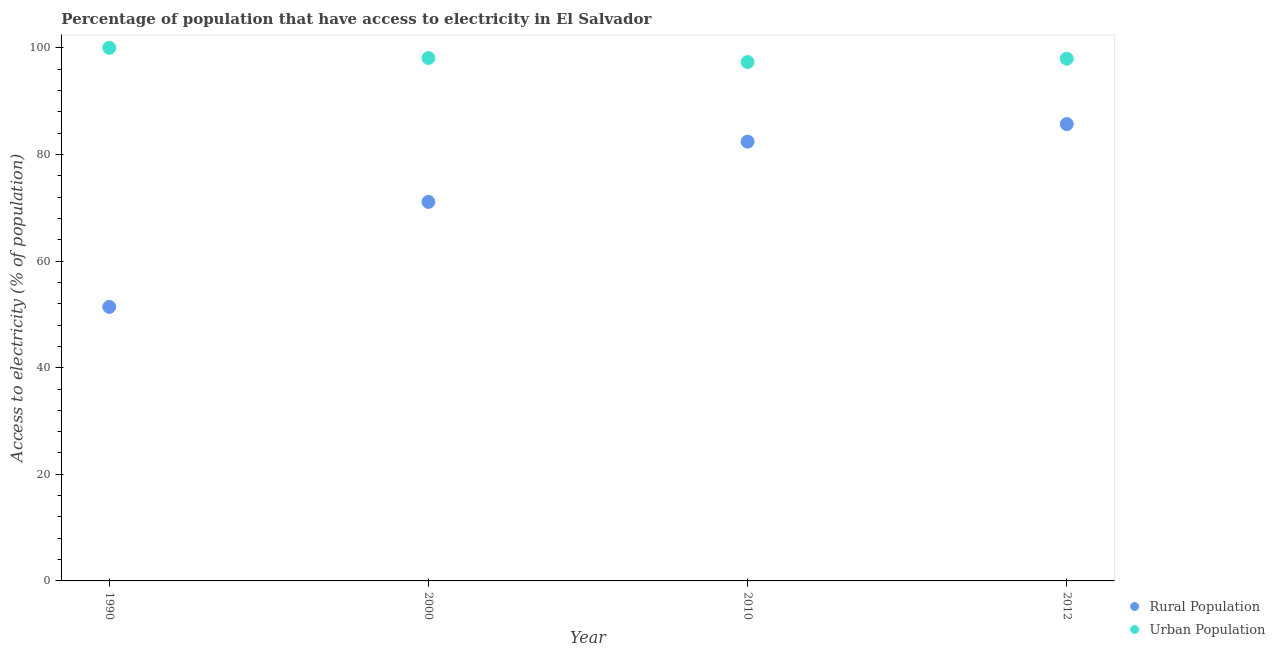How many different coloured dotlines are there?
Your answer should be compact. 2. What is the percentage of urban population having access to electricity in 2012?
Keep it short and to the point. 97.96. Across all years, what is the minimum percentage of rural population having access to electricity?
Your answer should be very brief. 51.4. In which year was the percentage of urban population having access to electricity maximum?
Your answer should be compact. 1990. What is the total percentage of urban population having access to electricity in the graph?
Make the answer very short. 393.39. What is the difference between the percentage of rural population having access to electricity in 2000 and that in 2012?
Your response must be concise. -14.6. What is the difference between the percentage of rural population having access to electricity in 2010 and the percentage of urban population having access to electricity in 2000?
Ensure brevity in your answer.  -15.69. What is the average percentage of rural population having access to electricity per year?
Your answer should be very brief. 72.65. In the year 2010, what is the difference between the percentage of urban population having access to electricity and percentage of rural population having access to electricity?
Ensure brevity in your answer.  14.93. In how many years, is the percentage of rural population having access to electricity greater than 8 %?
Provide a short and direct response. 4. What is the ratio of the percentage of rural population having access to electricity in 1990 to that in 2010?
Your answer should be very brief. 0.62. Is the percentage of urban population having access to electricity in 1990 less than that in 2012?
Keep it short and to the point. No. Is the difference between the percentage of urban population having access to electricity in 2010 and 2012 greater than the difference between the percentage of rural population having access to electricity in 2010 and 2012?
Your answer should be compact. Yes. What is the difference between the highest and the second highest percentage of rural population having access to electricity?
Make the answer very short. 3.3. What is the difference between the highest and the lowest percentage of urban population having access to electricity?
Make the answer very short. 2.67. In how many years, is the percentage of rural population having access to electricity greater than the average percentage of rural population having access to electricity taken over all years?
Provide a succinct answer. 2. Is the sum of the percentage of rural population having access to electricity in 2010 and 2012 greater than the maximum percentage of urban population having access to electricity across all years?
Ensure brevity in your answer.  Yes. How many dotlines are there?
Offer a terse response. 2. What is the difference between two consecutive major ticks on the Y-axis?
Keep it short and to the point. 20. Does the graph contain any zero values?
Make the answer very short. No. How many legend labels are there?
Offer a very short reply. 2. How are the legend labels stacked?
Your answer should be compact. Vertical. What is the title of the graph?
Give a very brief answer. Percentage of population that have access to electricity in El Salvador. Does "Highest 10% of population" appear as one of the legend labels in the graph?
Your response must be concise. No. What is the label or title of the X-axis?
Your answer should be compact. Year. What is the label or title of the Y-axis?
Ensure brevity in your answer.  Access to electricity (% of population). What is the Access to electricity (% of population) in Rural Population in 1990?
Your answer should be compact. 51.4. What is the Access to electricity (% of population) of Urban Population in 1990?
Your answer should be compact. 100. What is the Access to electricity (% of population) of Rural Population in 2000?
Provide a succinct answer. 71.1. What is the Access to electricity (% of population) of Urban Population in 2000?
Offer a terse response. 98.09. What is the Access to electricity (% of population) of Rural Population in 2010?
Your response must be concise. 82.4. What is the Access to electricity (% of population) in Urban Population in 2010?
Your response must be concise. 97.33. What is the Access to electricity (% of population) of Rural Population in 2012?
Give a very brief answer. 85.7. What is the Access to electricity (% of population) of Urban Population in 2012?
Provide a succinct answer. 97.96. Across all years, what is the maximum Access to electricity (% of population) of Rural Population?
Your response must be concise. 85.7. Across all years, what is the minimum Access to electricity (% of population) of Rural Population?
Provide a succinct answer. 51.4. Across all years, what is the minimum Access to electricity (% of population) of Urban Population?
Keep it short and to the point. 97.33. What is the total Access to electricity (% of population) of Rural Population in the graph?
Your response must be concise. 290.6. What is the total Access to electricity (% of population) of Urban Population in the graph?
Make the answer very short. 393.39. What is the difference between the Access to electricity (% of population) of Rural Population in 1990 and that in 2000?
Provide a succinct answer. -19.7. What is the difference between the Access to electricity (% of population) of Urban Population in 1990 and that in 2000?
Keep it short and to the point. 1.91. What is the difference between the Access to electricity (% of population) of Rural Population in 1990 and that in 2010?
Provide a short and direct response. -31. What is the difference between the Access to electricity (% of population) of Urban Population in 1990 and that in 2010?
Offer a terse response. 2.67. What is the difference between the Access to electricity (% of population) of Rural Population in 1990 and that in 2012?
Your response must be concise. -34.3. What is the difference between the Access to electricity (% of population) of Urban Population in 1990 and that in 2012?
Offer a very short reply. 2.04. What is the difference between the Access to electricity (% of population) in Rural Population in 2000 and that in 2010?
Offer a terse response. -11.3. What is the difference between the Access to electricity (% of population) of Urban Population in 2000 and that in 2010?
Provide a succinct answer. 0.75. What is the difference between the Access to electricity (% of population) in Rural Population in 2000 and that in 2012?
Offer a terse response. -14.6. What is the difference between the Access to electricity (% of population) in Urban Population in 2000 and that in 2012?
Offer a very short reply. 0.13. What is the difference between the Access to electricity (% of population) of Rural Population in 2010 and that in 2012?
Your answer should be very brief. -3.3. What is the difference between the Access to electricity (% of population) in Urban Population in 2010 and that in 2012?
Ensure brevity in your answer.  -0.63. What is the difference between the Access to electricity (% of population) of Rural Population in 1990 and the Access to electricity (% of population) of Urban Population in 2000?
Your answer should be compact. -46.69. What is the difference between the Access to electricity (% of population) in Rural Population in 1990 and the Access to electricity (% of population) in Urban Population in 2010?
Make the answer very short. -45.93. What is the difference between the Access to electricity (% of population) of Rural Population in 1990 and the Access to electricity (% of population) of Urban Population in 2012?
Offer a very short reply. -46.56. What is the difference between the Access to electricity (% of population) of Rural Population in 2000 and the Access to electricity (% of population) of Urban Population in 2010?
Give a very brief answer. -26.23. What is the difference between the Access to electricity (% of population) in Rural Population in 2000 and the Access to electricity (% of population) in Urban Population in 2012?
Provide a short and direct response. -26.86. What is the difference between the Access to electricity (% of population) in Rural Population in 2010 and the Access to electricity (% of population) in Urban Population in 2012?
Provide a short and direct response. -15.56. What is the average Access to electricity (% of population) of Rural Population per year?
Your response must be concise. 72.65. What is the average Access to electricity (% of population) of Urban Population per year?
Your answer should be very brief. 98.35. In the year 1990, what is the difference between the Access to electricity (% of population) in Rural Population and Access to electricity (% of population) in Urban Population?
Give a very brief answer. -48.6. In the year 2000, what is the difference between the Access to electricity (% of population) in Rural Population and Access to electricity (% of population) in Urban Population?
Make the answer very short. -26.99. In the year 2010, what is the difference between the Access to electricity (% of population) in Rural Population and Access to electricity (% of population) in Urban Population?
Offer a terse response. -14.93. In the year 2012, what is the difference between the Access to electricity (% of population) in Rural Population and Access to electricity (% of population) in Urban Population?
Provide a succinct answer. -12.26. What is the ratio of the Access to electricity (% of population) in Rural Population in 1990 to that in 2000?
Provide a succinct answer. 0.72. What is the ratio of the Access to electricity (% of population) in Urban Population in 1990 to that in 2000?
Give a very brief answer. 1.02. What is the ratio of the Access to electricity (% of population) in Rural Population in 1990 to that in 2010?
Offer a terse response. 0.62. What is the ratio of the Access to electricity (% of population) of Urban Population in 1990 to that in 2010?
Offer a very short reply. 1.03. What is the ratio of the Access to electricity (% of population) in Rural Population in 1990 to that in 2012?
Your response must be concise. 0.6. What is the ratio of the Access to electricity (% of population) of Urban Population in 1990 to that in 2012?
Your response must be concise. 1.02. What is the ratio of the Access to electricity (% of population) in Rural Population in 2000 to that in 2010?
Ensure brevity in your answer.  0.86. What is the ratio of the Access to electricity (% of population) of Rural Population in 2000 to that in 2012?
Your response must be concise. 0.83. What is the ratio of the Access to electricity (% of population) in Urban Population in 2000 to that in 2012?
Your answer should be very brief. 1. What is the ratio of the Access to electricity (% of population) in Rural Population in 2010 to that in 2012?
Give a very brief answer. 0.96. What is the difference between the highest and the second highest Access to electricity (% of population) in Urban Population?
Keep it short and to the point. 1.91. What is the difference between the highest and the lowest Access to electricity (% of population) in Rural Population?
Keep it short and to the point. 34.3. What is the difference between the highest and the lowest Access to electricity (% of population) in Urban Population?
Your response must be concise. 2.67. 